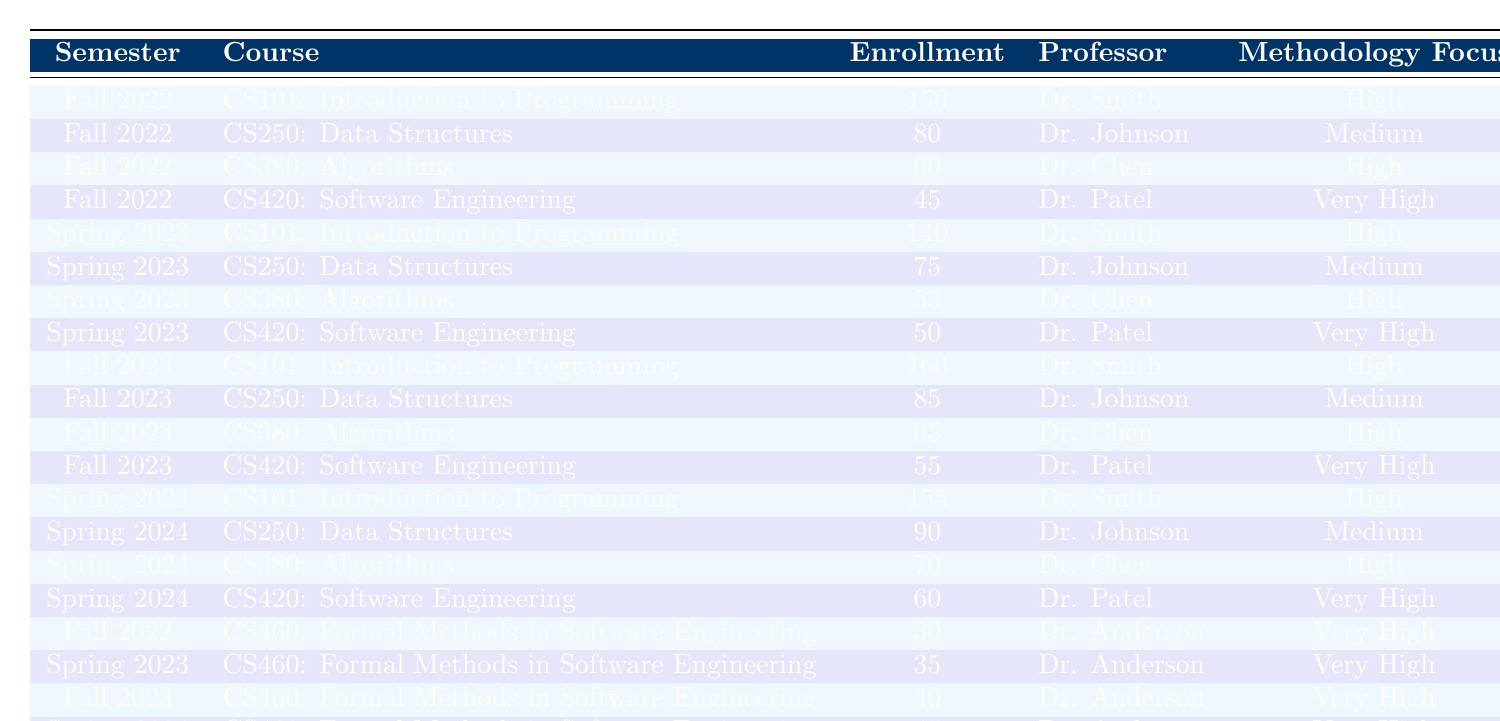What is the highest enrollment count in Fall 2023? In Fall 2023, the enrollment count for "CS101: Introduction to Programming" is 160, which is the highest among all the courses in that semester.
Answer: 160 What course had the least enrollment in Spring 2023? In Spring 2023, "CS420: Software Engineering" had the least enrollment with a count of 50, compared to other courses in that semester.
Answer: 50 What is the total enrollment for "CS460: Formal Methods in Software Engineering" over all semesters? Adding the enrollments for "CS460" in each semester gives 30 (Fall 2022) + 35 (Spring 2023) + 40 (Fall 2023) + 45 (Spring 2024) = 150.
Answer: 150 Did "CS250: Data Structures" have a higher enrollment in Spring 2024 than in Fall 2022? "CS250: Data Structures" had 90 in Spring 2024 and 80 in Fall 2022. Since 90 is greater than 80, this statement is true.
Answer: Yes What is the average enrollment for all courses taught by Dr. Anderson? The enrollments for courses taught by Dr. Anderson are 30, 35, 40, and 45. Summing these gives 30 + 35 + 40 + 45 = 150, and dividing by 4 (number of courses) gives an average of 150/4 = 37.5.
Answer: 37.5 Which course experienced the greatest increase in enrollment from Fall 2022 to Fall 2023? The enrollment increase for "CS101" from 150 to 160 is 10, for "CS250" it is 5, for "CS380" it is 5, and for "CS420" it is 10. The greatest increase occurs for "CS101" and "CS420", both with an increase of 10.
Answer: CS101 and CS420 What semester had the highest overall enrollment across all courses? To find this, we sum the enrollments for each semester: Fall 2022 (150 + 80 + 60 + 45 = 335), Spring 2023 (140 + 75 + 55 + 50 = 320), Fall 2023 (160 + 85 + 65 + 55 = 365), Spring 2024 (155 + 90 + 70 + 60 = 375). Spring 2024 has the highest total at 375.
Answer: Spring 2024 Is it true that "CS380: Algorithms" has consistently high enrollment across all semesters? The enrollments for "CS380" in each semester are 60 (Fall 2022), 55 (Spring 2023), 65 (Fall 2023), and 70 (Spring 2024), which shows fluctuation and indicates it does not have consistently high enrollment.
Answer: No What percentage of students enrolled in CS101 in Spring 2024 compared to total enrollment in that semester? The total enrollment in Spring 2024 is 155 (CS101) + 90 (CS250) + 70 (CS380) + 60 (CS420) = 375. The percentage for CS101 is (155/375) * 100 = 41.33%.
Answer: 41.33% Which professor had the highest average methodology focus rating? Each course's methodology focus is rated as Medium, High, or Very High. Since Dr. Patel only teaches "CS420" rated Very High and Dr. Anderson's courses are also Very High, they have the highest average focus rating.
Answer: Dr. Patel and Dr. Anderson 